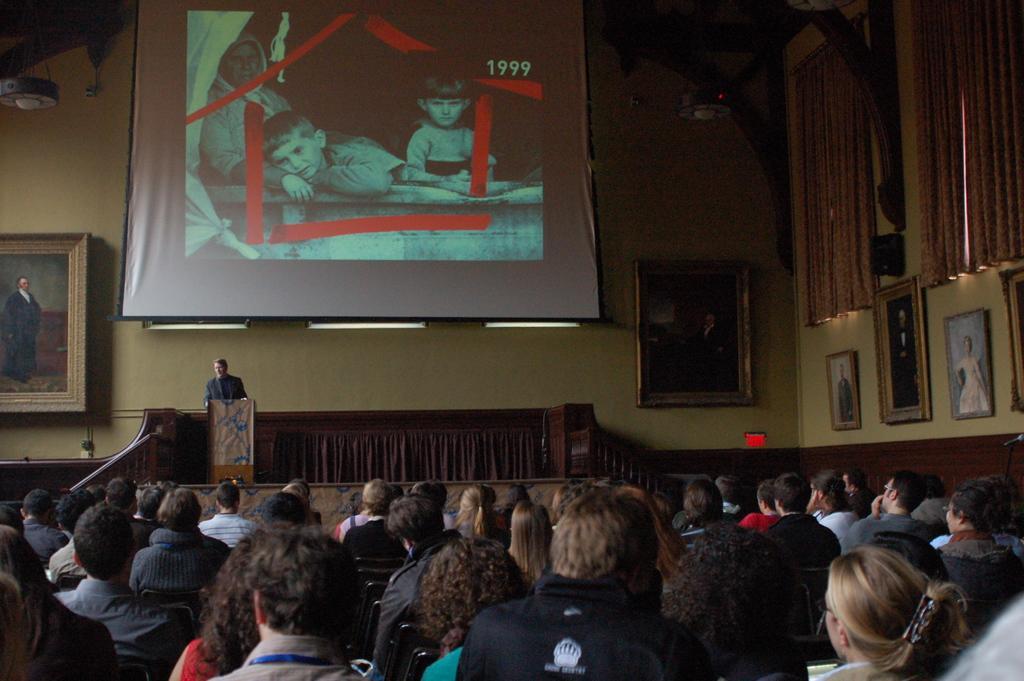Could you give a brief overview of what you see in this image? At the bottom I can see a crow is sitting on the chairs and a person is standing on the stage in front of a table. In the background I can see a wall, photo frames, screen, chandelier and curtains. This image is taken in a hall. 